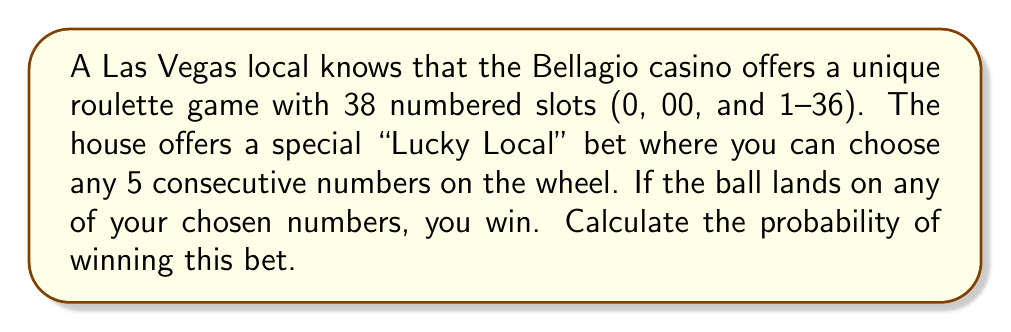Teach me how to tackle this problem. To solve this problem, we need to follow these steps:

1) First, let's understand what the question is asking:
   - There are 38 total slots on the wheel
   - We choose 5 consecutive numbers
   - We win if the ball lands on any of these 5 numbers

2) The probability of an event is calculated by:

   $$ P(\text{event}) = \frac{\text{number of favorable outcomes}}{\text{total number of possible outcomes}} $$

3) In this case:
   - The number of favorable outcomes is 5 (our chosen numbers)
   - The total number of possible outcomes is 38 (all slots on the wheel)

4) Therefore, the probability of winning is:

   $$ P(\text{winning}) = \frac{5}{38} $$

5) To simplify this fraction:
   
   $$ \frac{5}{38} = \frac{5}{38} \cdot \frac{1}{1} = \frac{5}{38} $$

   This fraction cannot be simplified further.

6) To express this as a decimal, we divide 5 by 38:

   $$ \frac{5}{38} \approx 0.1315789 $$

7) To express as a percentage, we multiply by 100:

   $$ 0.1315789 \times 100 \approx 13.16\% $$

Thus, the probability of winning this "Lucky Local" bet is $\frac{5}{38}$, or approximately 13.16%.
Answer: $\frac{5}{38}$ or approximately 13.16% 